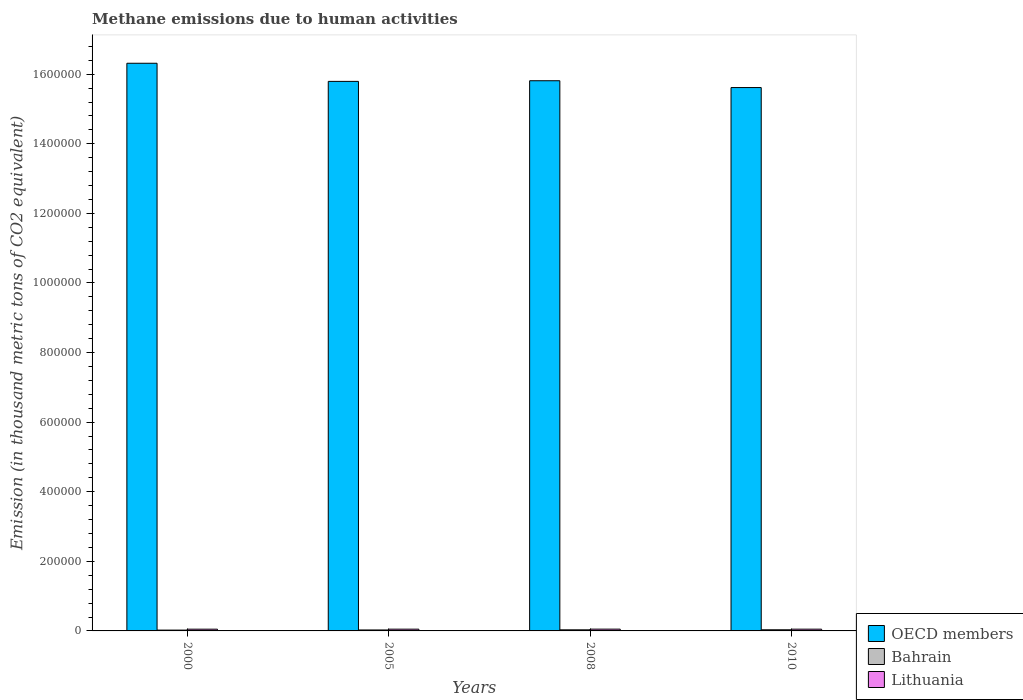How many different coloured bars are there?
Your answer should be compact. 3. How many groups of bars are there?
Provide a short and direct response. 4. Are the number of bars per tick equal to the number of legend labels?
Make the answer very short. Yes. How many bars are there on the 4th tick from the left?
Offer a terse response. 3. What is the label of the 2nd group of bars from the left?
Keep it short and to the point. 2005. What is the amount of methane emitted in OECD members in 2010?
Your response must be concise. 1.56e+06. Across all years, what is the maximum amount of methane emitted in OECD members?
Offer a terse response. 1.63e+06. Across all years, what is the minimum amount of methane emitted in Bahrain?
Offer a very short reply. 2366.2. What is the total amount of methane emitted in OECD members in the graph?
Provide a succinct answer. 6.35e+06. What is the difference between the amount of methane emitted in Bahrain in 2005 and that in 2010?
Your answer should be very brief. -550.3. What is the difference between the amount of methane emitted in Bahrain in 2008 and the amount of methane emitted in Lithuania in 2010?
Your answer should be compact. -1875.8. What is the average amount of methane emitted in OECD members per year?
Your response must be concise. 1.59e+06. In the year 2000, what is the difference between the amount of methane emitted in Bahrain and amount of methane emitted in OECD members?
Provide a short and direct response. -1.63e+06. What is the ratio of the amount of methane emitted in Lithuania in 2005 to that in 2010?
Keep it short and to the point. 1. Is the amount of methane emitted in Bahrain in 2000 less than that in 2008?
Your response must be concise. Yes. Is the difference between the amount of methane emitted in Bahrain in 2005 and 2008 greater than the difference between the amount of methane emitted in OECD members in 2005 and 2008?
Offer a very short reply. Yes. What is the difference between the highest and the second highest amount of methane emitted in Bahrain?
Ensure brevity in your answer.  135.9. What is the difference between the highest and the lowest amount of methane emitted in Lithuania?
Offer a very short reply. 155.6. Is the sum of the amount of methane emitted in Bahrain in 2008 and 2010 greater than the maximum amount of methane emitted in Lithuania across all years?
Your answer should be very brief. Yes. What does the 3rd bar from the left in 2000 represents?
Make the answer very short. Lithuania. What does the 2nd bar from the right in 2008 represents?
Your answer should be compact. Bahrain. How many bars are there?
Offer a very short reply. 12. Are all the bars in the graph horizontal?
Provide a succinct answer. No. How many years are there in the graph?
Offer a terse response. 4. Are the values on the major ticks of Y-axis written in scientific E-notation?
Make the answer very short. No. Does the graph contain any zero values?
Give a very brief answer. No. Does the graph contain grids?
Offer a terse response. No. What is the title of the graph?
Offer a terse response. Methane emissions due to human activities. What is the label or title of the X-axis?
Give a very brief answer. Years. What is the label or title of the Y-axis?
Provide a succinct answer. Emission (in thousand metric tons of CO2 equivalent). What is the Emission (in thousand metric tons of CO2 equivalent) in OECD members in 2000?
Your response must be concise. 1.63e+06. What is the Emission (in thousand metric tons of CO2 equivalent) of Bahrain in 2000?
Offer a terse response. 2366.2. What is the Emission (in thousand metric tons of CO2 equivalent) of Lithuania in 2000?
Provide a short and direct response. 5000.2. What is the Emission (in thousand metric tons of CO2 equivalent) of OECD members in 2005?
Keep it short and to the point. 1.58e+06. What is the Emission (in thousand metric tons of CO2 equivalent) of Bahrain in 2005?
Your answer should be compact. 2762. What is the Emission (in thousand metric tons of CO2 equivalent) in Lithuania in 2005?
Keep it short and to the point. 5042.2. What is the Emission (in thousand metric tons of CO2 equivalent) in OECD members in 2008?
Provide a succinct answer. 1.58e+06. What is the Emission (in thousand metric tons of CO2 equivalent) in Bahrain in 2008?
Offer a very short reply. 3176.4. What is the Emission (in thousand metric tons of CO2 equivalent) in Lithuania in 2008?
Give a very brief answer. 5155.8. What is the Emission (in thousand metric tons of CO2 equivalent) of OECD members in 2010?
Your answer should be very brief. 1.56e+06. What is the Emission (in thousand metric tons of CO2 equivalent) of Bahrain in 2010?
Keep it short and to the point. 3312.3. What is the Emission (in thousand metric tons of CO2 equivalent) of Lithuania in 2010?
Provide a short and direct response. 5052.2. Across all years, what is the maximum Emission (in thousand metric tons of CO2 equivalent) in OECD members?
Your answer should be compact. 1.63e+06. Across all years, what is the maximum Emission (in thousand metric tons of CO2 equivalent) of Bahrain?
Ensure brevity in your answer.  3312.3. Across all years, what is the maximum Emission (in thousand metric tons of CO2 equivalent) in Lithuania?
Provide a short and direct response. 5155.8. Across all years, what is the minimum Emission (in thousand metric tons of CO2 equivalent) of OECD members?
Give a very brief answer. 1.56e+06. Across all years, what is the minimum Emission (in thousand metric tons of CO2 equivalent) in Bahrain?
Offer a terse response. 2366.2. Across all years, what is the minimum Emission (in thousand metric tons of CO2 equivalent) of Lithuania?
Give a very brief answer. 5000.2. What is the total Emission (in thousand metric tons of CO2 equivalent) of OECD members in the graph?
Provide a short and direct response. 6.35e+06. What is the total Emission (in thousand metric tons of CO2 equivalent) of Bahrain in the graph?
Provide a short and direct response. 1.16e+04. What is the total Emission (in thousand metric tons of CO2 equivalent) in Lithuania in the graph?
Your answer should be very brief. 2.03e+04. What is the difference between the Emission (in thousand metric tons of CO2 equivalent) of OECD members in 2000 and that in 2005?
Ensure brevity in your answer.  5.21e+04. What is the difference between the Emission (in thousand metric tons of CO2 equivalent) of Bahrain in 2000 and that in 2005?
Your response must be concise. -395.8. What is the difference between the Emission (in thousand metric tons of CO2 equivalent) in Lithuania in 2000 and that in 2005?
Your answer should be very brief. -42. What is the difference between the Emission (in thousand metric tons of CO2 equivalent) of OECD members in 2000 and that in 2008?
Ensure brevity in your answer.  5.02e+04. What is the difference between the Emission (in thousand metric tons of CO2 equivalent) of Bahrain in 2000 and that in 2008?
Your answer should be compact. -810.2. What is the difference between the Emission (in thousand metric tons of CO2 equivalent) in Lithuania in 2000 and that in 2008?
Your response must be concise. -155.6. What is the difference between the Emission (in thousand metric tons of CO2 equivalent) in OECD members in 2000 and that in 2010?
Provide a short and direct response. 6.98e+04. What is the difference between the Emission (in thousand metric tons of CO2 equivalent) of Bahrain in 2000 and that in 2010?
Your response must be concise. -946.1. What is the difference between the Emission (in thousand metric tons of CO2 equivalent) of Lithuania in 2000 and that in 2010?
Your response must be concise. -52. What is the difference between the Emission (in thousand metric tons of CO2 equivalent) of OECD members in 2005 and that in 2008?
Offer a very short reply. -1871.6. What is the difference between the Emission (in thousand metric tons of CO2 equivalent) of Bahrain in 2005 and that in 2008?
Make the answer very short. -414.4. What is the difference between the Emission (in thousand metric tons of CO2 equivalent) of Lithuania in 2005 and that in 2008?
Provide a short and direct response. -113.6. What is the difference between the Emission (in thousand metric tons of CO2 equivalent) in OECD members in 2005 and that in 2010?
Your answer should be very brief. 1.77e+04. What is the difference between the Emission (in thousand metric tons of CO2 equivalent) of Bahrain in 2005 and that in 2010?
Provide a short and direct response. -550.3. What is the difference between the Emission (in thousand metric tons of CO2 equivalent) of Lithuania in 2005 and that in 2010?
Your answer should be compact. -10. What is the difference between the Emission (in thousand metric tons of CO2 equivalent) of OECD members in 2008 and that in 2010?
Your response must be concise. 1.96e+04. What is the difference between the Emission (in thousand metric tons of CO2 equivalent) in Bahrain in 2008 and that in 2010?
Your answer should be compact. -135.9. What is the difference between the Emission (in thousand metric tons of CO2 equivalent) in Lithuania in 2008 and that in 2010?
Provide a short and direct response. 103.6. What is the difference between the Emission (in thousand metric tons of CO2 equivalent) in OECD members in 2000 and the Emission (in thousand metric tons of CO2 equivalent) in Bahrain in 2005?
Offer a very short reply. 1.63e+06. What is the difference between the Emission (in thousand metric tons of CO2 equivalent) of OECD members in 2000 and the Emission (in thousand metric tons of CO2 equivalent) of Lithuania in 2005?
Offer a very short reply. 1.63e+06. What is the difference between the Emission (in thousand metric tons of CO2 equivalent) of Bahrain in 2000 and the Emission (in thousand metric tons of CO2 equivalent) of Lithuania in 2005?
Offer a very short reply. -2676. What is the difference between the Emission (in thousand metric tons of CO2 equivalent) of OECD members in 2000 and the Emission (in thousand metric tons of CO2 equivalent) of Bahrain in 2008?
Provide a succinct answer. 1.63e+06. What is the difference between the Emission (in thousand metric tons of CO2 equivalent) of OECD members in 2000 and the Emission (in thousand metric tons of CO2 equivalent) of Lithuania in 2008?
Provide a succinct answer. 1.63e+06. What is the difference between the Emission (in thousand metric tons of CO2 equivalent) of Bahrain in 2000 and the Emission (in thousand metric tons of CO2 equivalent) of Lithuania in 2008?
Give a very brief answer. -2789.6. What is the difference between the Emission (in thousand metric tons of CO2 equivalent) of OECD members in 2000 and the Emission (in thousand metric tons of CO2 equivalent) of Bahrain in 2010?
Ensure brevity in your answer.  1.63e+06. What is the difference between the Emission (in thousand metric tons of CO2 equivalent) of OECD members in 2000 and the Emission (in thousand metric tons of CO2 equivalent) of Lithuania in 2010?
Offer a terse response. 1.63e+06. What is the difference between the Emission (in thousand metric tons of CO2 equivalent) of Bahrain in 2000 and the Emission (in thousand metric tons of CO2 equivalent) of Lithuania in 2010?
Ensure brevity in your answer.  -2686. What is the difference between the Emission (in thousand metric tons of CO2 equivalent) of OECD members in 2005 and the Emission (in thousand metric tons of CO2 equivalent) of Bahrain in 2008?
Ensure brevity in your answer.  1.58e+06. What is the difference between the Emission (in thousand metric tons of CO2 equivalent) in OECD members in 2005 and the Emission (in thousand metric tons of CO2 equivalent) in Lithuania in 2008?
Give a very brief answer. 1.57e+06. What is the difference between the Emission (in thousand metric tons of CO2 equivalent) of Bahrain in 2005 and the Emission (in thousand metric tons of CO2 equivalent) of Lithuania in 2008?
Offer a very short reply. -2393.8. What is the difference between the Emission (in thousand metric tons of CO2 equivalent) of OECD members in 2005 and the Emission (in thousand metric tons of CO2 equivalent) of Bahrain in 2010?
Provide a short and direct response. 1.58e+06. What is the difference between the Emission (in thousand metric tons of CO2 equivalent) of OECD members in 2005 and the Emission (in thousand metric tons of CO2 equivalent) of Lithuania in 2010?
Provide a succinct answer. 1.57e+06. What is the difference between the Emission (in thousand metric tons of CO2 equivalent) of Bahrain in 2005 and the Emission (in thousand metric tons of CO2 equivalent) of Lithuania in 2010?
Your answer should be compact. -2290.2. What is the difference between the Emission (in thousand metric tons of CO2 equivalent) in OECD members in 2008 and the Emission (in thousand metric tons of CO2 equivalent) in Bahrain in 2010?
Ensure brevity in your answer.  1.58e+06. What is the difference between the Emission (in thousand metric tons of CO2 equivalent) in OECD members in 2008 and the Emission (in thousand metric tons of CO2 equivalent) in Lithuania in 2010?
Keep it short and to the point. 1.58e+06. What is the difference between the Emission (in thousand metric tons of CO2 equivalent) in Bahrain in 2008 and the Emission (in thousand metric tons of CO2 equivalent) in Lithuania in 2010?
Offer a very short reply. -1875.8. What is the average Emission (in thousand metric tons of CO2 equivalent) of OECD members per year?
Give a very brief answer. 1.59e+06. What is the average Emission (in thousand metric tons of CO2 equivalent) in Bahrain per year?
Offer a terse response. 2904.22. What is the average Emission (in thousand metric tons of CO2 equivalent) of Lithuania per year?
Give a very brief answer. 5062.6. In the year 2000, what is the difference between the Emission (in thousand metric tons of CO2 equivalent) in OECD members and Emission (in thousand metric tons of CO2 equivalent) in Bahrain?
Ensure brevity in your answer.  1.63e+06. In the year 2000, what is the difference between the Emission (in thousand metric tons of CO2 equivalent) of OECD members and Emission (in thousand metric tons of CO2 equivalent) of Lithuania?
Make the answer very short. 1.63e+06. In the year 2000, what is the difference between the Emission (in thousand metric tons of CO2 equivalent) in Bahrain and Emission (in thousand metric tons of CO2 equivalent) in Lithuania?
Give a very brief answer. -2634. In the year 2005, what is the difference between the Emission (in thousand metric tons of CO2 equivalent) of OECD members and Emission (in thousand metric tons of CO2 equivalent) of Bahrain?
Ensure brevity in your answer.  1.58e+06. In the year 2005, what is the difference between the Emission (in thousand metric tons of CO2 equivalent) of OECD members and Emission (in thousand metric tons of CO2 equivalent) of Lithuania?
Give a very brief answer. 1.57e+06. In the year 2005, what is the difference between the Emission (in thousand metric tons of CO2 equivalent) in Bahrain and Emission (in thousand metric tons of CO2 equivalent) in Lithuania?
Provide a short and direct response. -2280.2. In the year 2008, what is the difference between the Emission (in thousand metric tons of CO2 equivalent) in OECD members and Emission (in thousand metric tons of CO2 equivalent) in Bahrain?
Ensure brevity in your answer.  1.58e+06. In the year 2008, what is the difference between the Emission (in thousand metric tons of CO2 equivalent) of OECD members and Emission (in thousand metric tons of CO2 equivalent) of Lithuania?
Your answer should be compact. 1.58e+06. In the year 2008, what is the difference between the Emission (in thousand metric tons of CO2 equivalent) of Bahrain and Emission (in thousand metric tons of CO2 equivalent) of Lithuania?
Keep it short and to the point. -1979.4. In the year 2010, what is the difference between the Emission (in thousand metric tons of CO2 equivalent) in OECD members and Emission (in thousand metric tons of CO2 equivalent) in Bahrain?
Offer a terse response. 1.56e+06. In the year 2010, what is the difference between the Emission (in thousand metric tons of CO2 equivalent) in OECD members and Emission (in thousand metric tons of CO2 equivalent) in Lithuania?
Ensure brevity in your answer.  1.56e+06. In the year 2010, what is the difference between the Emission (in thousand metric tons of CO2 equivalent) in Bahrain and Emission (in thousand metric tons of CO2 equivalent) in Lithuania?
Make the answer very short. -1739.9. What is the ratio of the Emission (in thousand metric tons of CO2 equivalent) in OECD members in 2000 to that in 2005?
Provide a succinct answer. 1.03. What is the ratio of the Emission (in thousand metric tons of CO2 equivalent) of Bahrain in 2000 to that in 2005?
Provide a succinct answer. 0.86. What is the ratio of the Emission (in thousand metric tons of CO2 equivalent) of OECD members in 2000 to that in 2008?
Make the answer very short. 1.03. What is the ratio of the Emission (in thousand metric tons of CO2 equivalent) of Bahrain in 2000 to that in 2008?
Make the answer very short. 0.74. What is the ratio of the Emission (in thousand metric tons of CO2 equivalent) of Lithuania in 2000 to that in 2008?
Provide a succinct answer. 0.97. What is the ratio of the Emission (in thousand metric tons of CO2 equivalent) of OECD members in 2000 to that in 2010?
Ensure brevity in your answer.  1.04. What is the ratio of the Emission (in thousand metric tons of CO2 equivalent) in Bahrain in 2000 to that in 2010?
Give a very brief answer. 0.71. What is the ratio of the Emission (in thousand metric tons of CO2 equivalent) of Lithuania in 2000 to that in 2010?
Provide a succinct answer. 0.99. What is the ratio of the Emission (in thousand metric tons of CO2 equivalent) in Bahrain in 2005 to that in 2008?
Keep it short and to the point. 0.87. What is the ratio of the Emission (in thousand metric tons of CO2 equivalent) of Lithuania in 2005 to that in 2008?
Offer a very short reply. 0.98. What is the ratio of the Emission (in thousand metric tons of CO2 equivalent) of OECD members in 2005 to that in 2010?
Provide a succinct answer. 1.01. What is the ratio of the Emission (in thousand metric tons of CO2 equivalent) of Bahrain in 2005 to that in 2010?
Offer a terse response. 0.83. What is the ratio of the Emission (in thousand metric tons of CO2 equivalent) in Lithuania in 2005 to that in 2010?
Your answer should be compact. 1. What is the ratio of the Emission (in thousand metric tons of CO2 equivalent) of OECD members in 2008 to that in 2010?
Provide a short and direct response. 1.01. What is the ratio of the Emission (in thousand metric tons of CO2 equivalent) in Bahrain in 2008 to that in 2010?
Ensure brevity in your answer.  0.96. What is the ratio of the Emission (in thousand metric tons of CO2 equivalent) in Lithuania in 2008 to that in 2010?
Provide a succinct answer. 1.02. What is the difference between the highest and the second highest Emission (in thousand metric tons of CO2 equivalent) of OECD members?
Make the answer very short. 5.02e+04. What is the difference between the highest and the second highest Emission (in thousand metric tons of CO2 equivalent) of Bahrain?
Offer a terse response. 135.9. What is the difference between the highest and the second highest Emission (in thousand metric tons of CO2 equivalent) of Lithuania?
Keep it short and to the point. 103.6. What is the difference between the highest and the lowest Emission (in thousand metric tons of CO2 equivalent) of OECD members?
Your answer should be very brief. 6.98e+04. What is the difference between the highest and the lowest Emission (in thousand metric tons of CO2 equivalent) in Bahrain?
Keep it short and to the point. 946.1. What is the difference between the highest and the lowest Emission (in thousand metric tons of CO2 equivalent) in Lithuania?
Your answer should be compact. 155.6. 